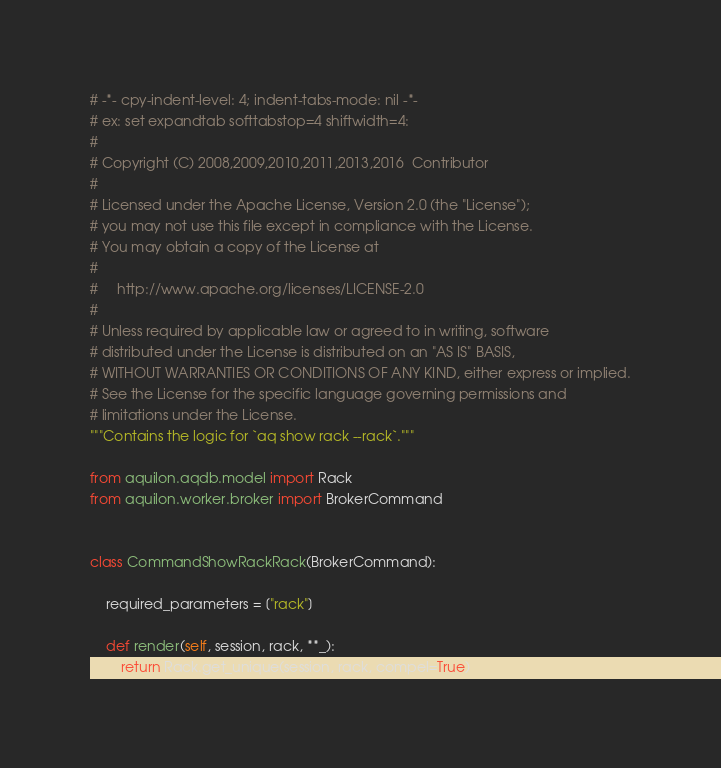Convert code to text. <code><loc_0><loc_0><loc_500><loc_500><_Python_># -*- cpy-indent-level: 4; indent-tabs-mode: nil -*-
# ex: set expandtab softtabstop=4 shiftwidth=4:
#
# Copyright (C) 2008,2009,2010,2011,2013,2016  Contributor
#
# Licensed under the Apache License, Version 2.0 (the "License");
# you may not use this file except in compliance with the License.
# You may obtain a copy of the License at
#
#     http://www.apache.org/licenses/LICENSE-2.0
#
# Unless required by applicable law or agreed to in writing, software
# distributed under the License is distributed on an "AS IS" BASIS,
# WITHOUT WARRANTIES OR CONDITIONS OF ANY KIND, either express or implied.
# See the License for the specific language governing permissions and
# limitations under the License.
"""Contains the logic for `aq show rack --rack`."""

from aquilon.aqdb.model import Rack
from aquilon.worker.broker import BrokerCommand


class CommandShowRackRack(BrokerCommand):

    required_parameters = ["rack"]

    def render(self, session, rack, **_):
        return Rack.get_unique(session, rack, compel=True)
</code> 